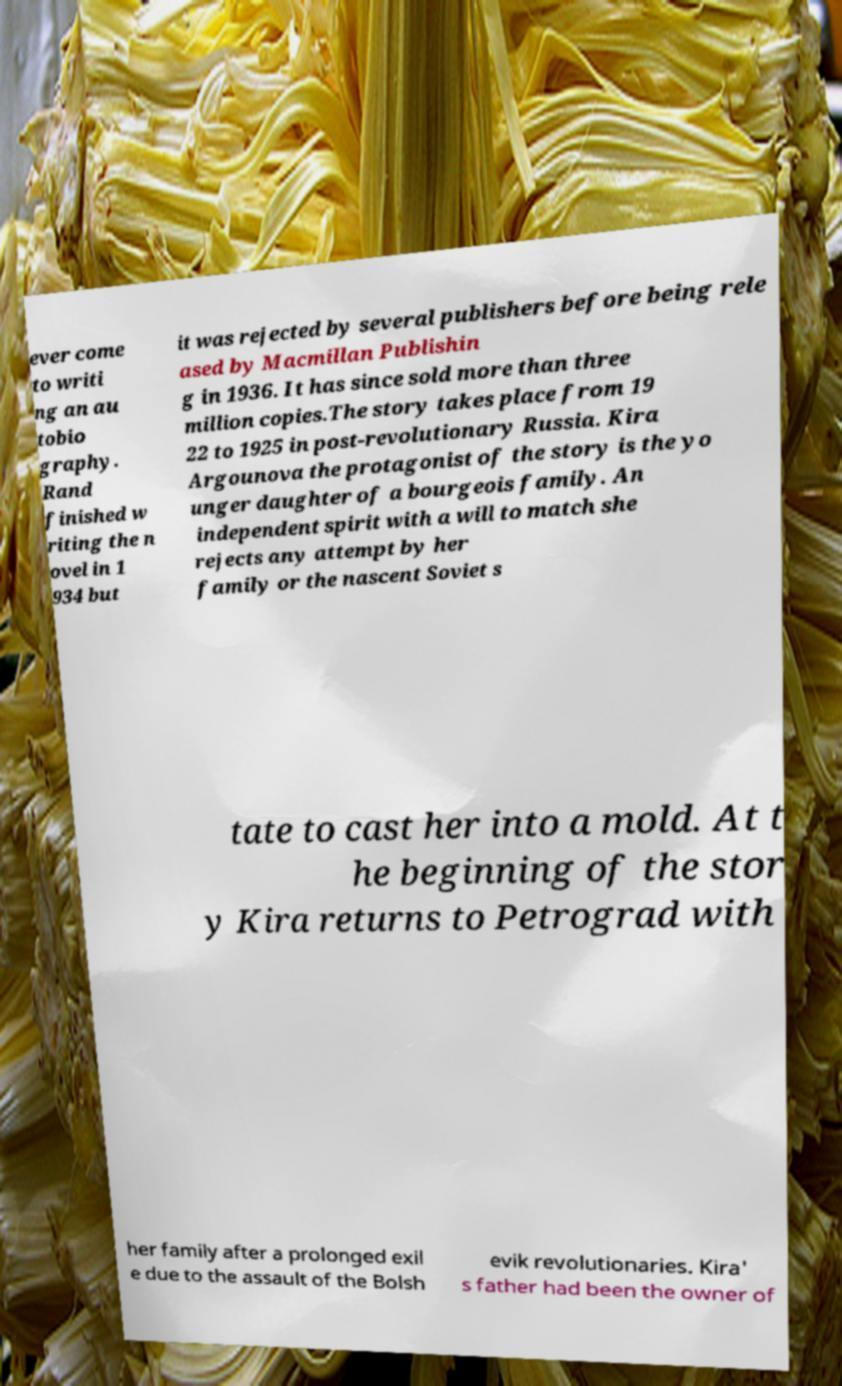I need the written content from this picture converted into text. Can you do that? ever come to writi ng an au tobio graphy. Rand finished w riting the n ovel in 1 934 but it was rejected by several publishers before being rele ased by Macmillan Publishin g in 1936. It has since sold more than three million copies.The story takes place from 19 22 to 1925 in post-revolutionary Russia. Kira Argounova the protagonist of the story is the yo unger daughter of a bourgeois family. An independent spirit with a will to match she rejects any attempt by her family or the nascent Soviet s tate to cast her into a mold. At t he beginning of the stor y Kira returns to Petrograd with her family after a prolonged exil e due to the assault of the Bolsh evik revolutionaries. Kira' s father had been the owner of 